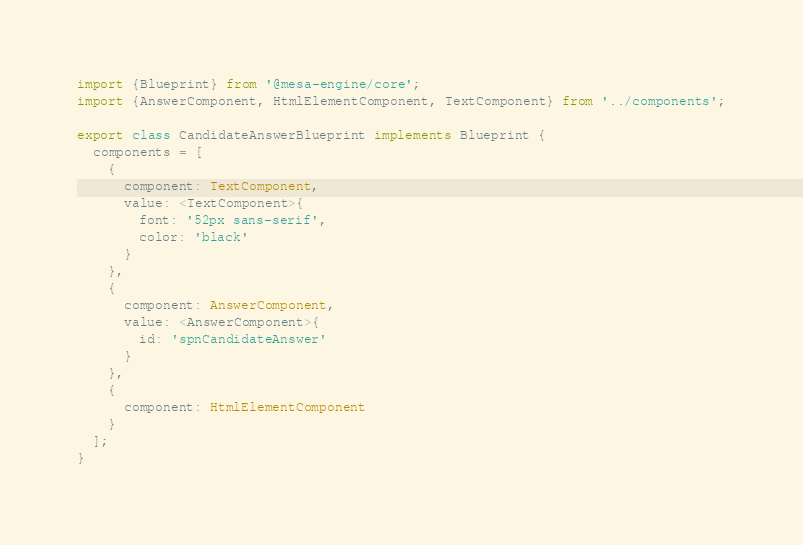Convert code to text. <code><loc_0><loc_0><loc_500><loc_500><_TypeScript_>import {Blueprint} from '@mesa-engine/core';
import {AnswerComponent, HtmlElementComponent, TextComponent} from '../components';

export class CandidateAnswerBlueprint implements Blueprint {
  components = [
    {
      component: TextComponent,
      value: <TextComponent>{
        font: '52px sans-serif',
        color: 'black'
      }
    },
    {
      component: AnswerComponent,
      value: <AnswerComponent>{
        id: 'spnCandidateAnswer'
      }
    },
    {
      component: HtmlElementComponent
    }
  ];
}
</code> 